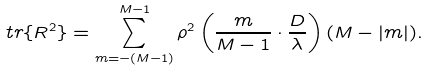<formula> <loc_0><loc_0><loc_500><loc_500>t r \{ R ^ { 2 } \} = \sum _ { m = - ( M - 1 ) } ^ { M - 1 } \rho ^ { 2 } \left ( \frac { m } { M - 1 } \cdot \frac { D } { \lambda } \right ) ( M - | m | ) .</formula> 